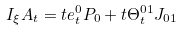<formula> <loc_0><loc_0><loc_500><loc_500>I _ { \xi } A _ { t } = t e ^ { 0 } _ { t } P _ { 0 } + t \Theta ^ { 0 1 } _ { t } J _ { 0 1 }</formula> 